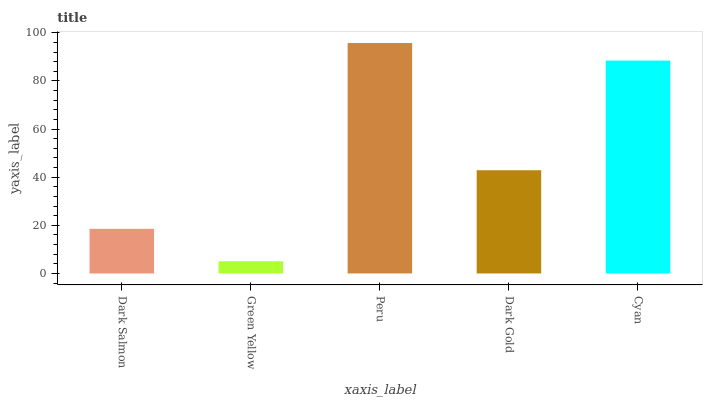Is Green Yellow the minimum?
Answer yes or no. Yes. Is Peru the maximum?
Answer yes or no. Yes. Is Peru the minimum?
Answer yes or no. No. Is Green Yellow the maximum?
Answer yes or no. No. Is Peru greater than Green Yellow?
Answer yes or no. Yes. Is Green Yellow less than Peru?
Answer yes or no. Yes. Is Green Yellow greater than Peru?
Answer yes or no. No. Is Peru less than Green Yellow?
Answer yes or no. No. Is Dark Gold the high median?
Answer yes or no. Yes. Is Dark Gold the low median?
Answer yes or no. Yes. Is Dark Salmon the high median?
Answer yes or no. No. Is Green Yellow the low median?
Answer yes or no. No. 